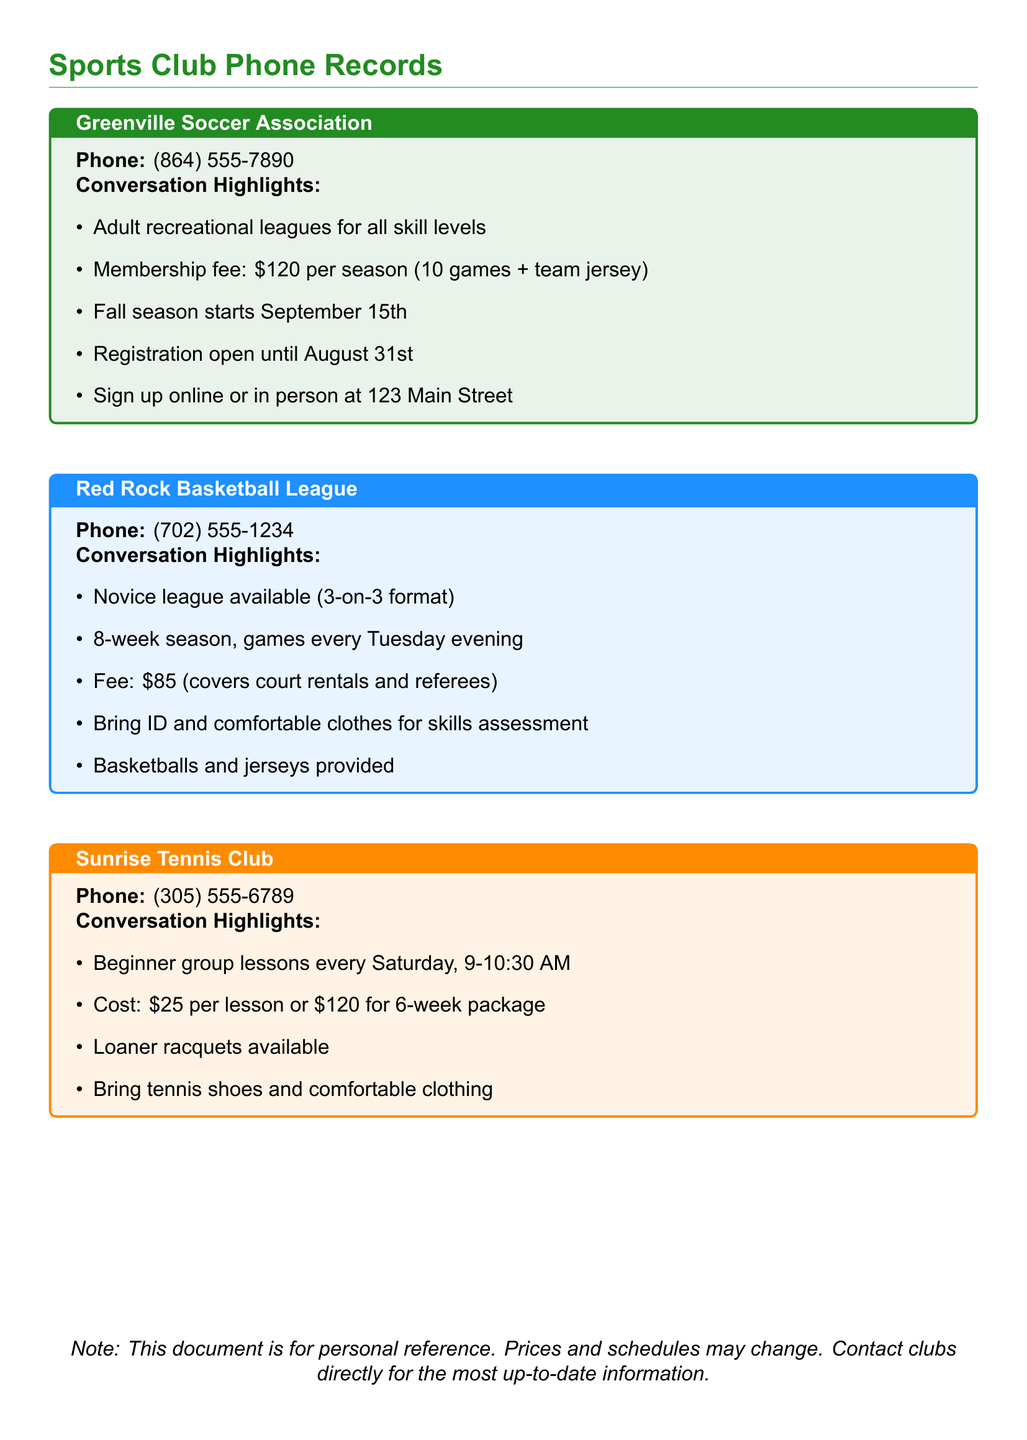What is the phone number for Greenville Soccer Association? This information is stated directly in the document under the Greenville Soccer Association section.
Answer: (864) 555-7890 What is the membership fee for the Greenville Soccer Association? The document specifies the membership fee in the highlights for the Greenville Soccer Association.
Answer: $120 When does the fall season start for Greenville Soccer Association? The fall season start date is given in the conversation highlights.
Answer: September 15th How many weeks is the Red Rock Basketball League season? The length of the season is mentioned clearly in the Red Rock Basketball League section of the document.
Answer: 8 weeks What is the cost for a 6-week tennis lesson package at Sunrise Tennis Club? The document highlights the cost for the complete package, which is indicated in the Sunrise Tennis Club section.
Answer: $120 What type of league format does the Red Rock Basketball League offer? The document mentions the type of league format available under Red Rock Basketball League highlights.
Answer: 3-on-3 format Which club provides loaner racquets for tennis lessons? The mention of loaner racquets is specified in the Sunrise Tennis Club section.
Answer: Sunrise Tennis Club What is required to bring for the skills assessment in the Red Rock Basketball League? The document clearly states the requirements under the Red Rock Basketball League section.
Answer: ID and comfortable clothes What day are beginner group lessons held at Sunrise Tennis Club? The document notes the day of the week that the lessons are scheduled in the Sunrise Tennis Club section.
Answer: Saturday 